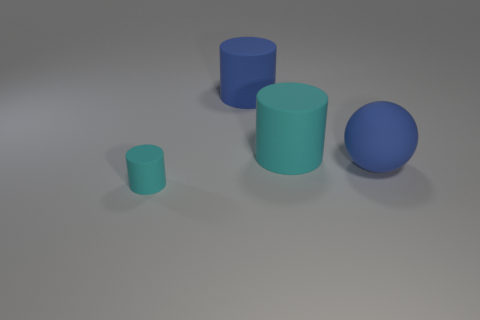Add 1 large things. How many objects exist? 5 Subtract all balls. How many objects are left? 3 Add 2 small cyan cylinders. How many small cyan cylinders are left? 3 Add 3 big spheres. How many big spheres exist? 4 Subtract 0 red cubes. How many objects are left? 4 Subtract all big blue matte spheres. Subtract all small cyan rubber cylinders. How many objects are left? 2 